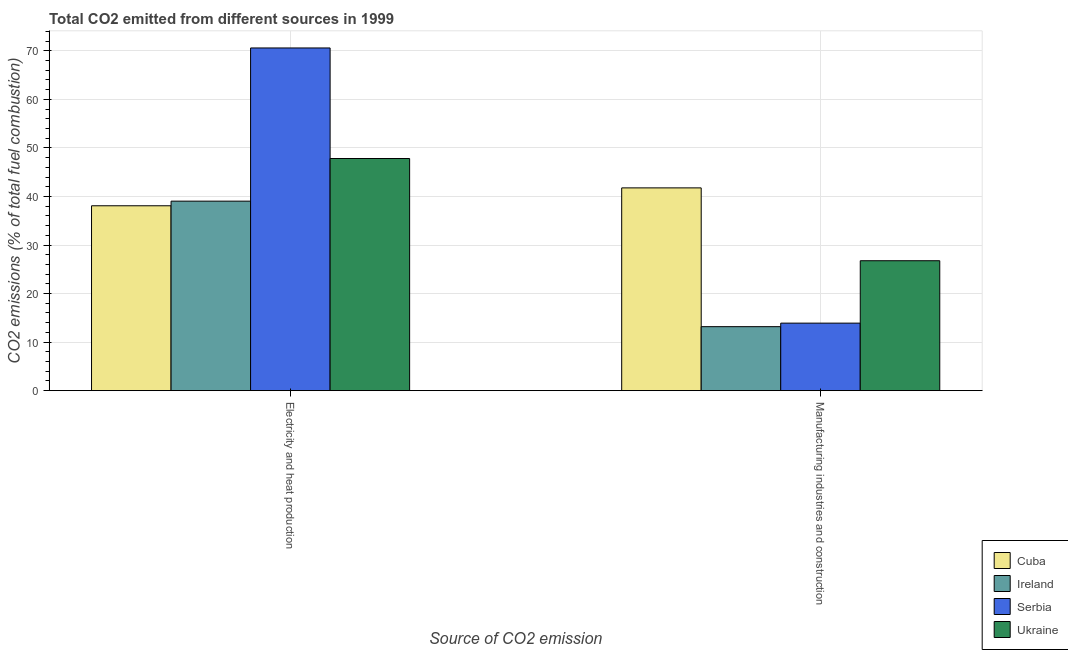How many groups of bars are there?
Provide a succinct answer. 2. How many bars are there on the 2nd tick from the left?
Keep it short and to the point. 4. What is the label of the 2nd group of bars from the left?
Provide a succinct answer. Manufacturing industries and construction. What is the co2 emissions due to manufacturing industries in Ireland?
Give a very brief answer. 13.18. Across all countries, what is the maximum co2 emissions due to electricity and heat production?
Keep it short and to the point. 70.6. Across all countries, what is the minimum co2 emissions due to electricity and heat production?
Provide a succinct answer. 38.09. In which country was the co2 emissions due to electricity and heat production maximum?
Give a very brief answer. Serbia. In which country was the co2 emissions due to manufacturing industries minimum?
Keep it short and to the point. Ireland. What is the total co2 emissions due to manufacturing industries in the graph?
Provide a succinct answer. 95.62. What is the difference between the co2 emissions due to electricity and heat production in Ukraine and that in Ireland?
Keep it short and to the point. 8.79. What is the difference between the co2 emissions due to manufacturing industries in Ukraine and the co2 emissions due to electricity and heat production in Ireland?
Offer a terse response. -12.27. What is the average co2 emissions due to electricity and heat production per country?
Your answer should be compact. 48.89. What is the difference between the co2 emissions due to electricity and heat production and co2 emissions due to manufacturing industries in Serbia?
Your response must be concise. 56.69. In how many countries, is the co2 emissions due to electricity and heat production greater than 6 %?
Offer a terse response. 4. What is the ratio of the co2 emissions due to manufacturing industries in Cuba to that in Serbia?
Offer a terse response. 3. Is the co2 emissions due to manufacturing industries in Ukraine less than that in Ireland?
Give a very brief answer. No. In how many countries, is the co2 emissions due to manufacturing industries greater than the average co2 emissions due to manufacturing industries taken over all countries?
Provide a succinct answer. 2. What does the 1st bar from the left in Manufacturing industries and construction represents?
Your response must be concise. Cuba. What does the 1st bar from the right in Electricity and heat production represents?
Provide a short and direct response. Ukraine. How many bars are there?
Keep it short and to the point. 8. Are all the bars in the graph horizontal?
Your answer should be compact. No. Does the graph contain any zero values?
Your answer should be compact. No. Where does the legend appear in the graph?
Make the answer very short. Bottom right. How many legend labels are there?
Your response must be concise. 4. How are the legend labels stacked?
Offer a very short reply. Vertical. What is the title of the graph?
Ensure brevity in your answer.  Total CO2 emitted from different sources in 1999. Does "Cambodia" appear as one of the legend labels in the graph?
Provide a succinct answer. No. What is the label or title of the X-axis?
Give a very brief answer. Source of CO2 emission. What is the label or title of the Y-axis?
Your answer should be very brief. CO2 emissions (% of total fuel combustion). What is the CO2 emissions (% of total fuel combustion) of Cuba in Electricity and heat production?
Offer a very short reply. 38.09. What is the CO2 emissions (% of total fuel combustion) in Ireland in Electricity and heat production?
Your answer should be compact. 39.04. What is the CO2 emissions (% of total fuel combustion) of Serbia in Electricity and heat production?
Your response must be concise. 70.6. What is the CO2 emissions (% of total fuel combustion) of Ukraine in Electricity and heat production?
Offer a very short reply. 47.82. What is the CO2 emissions (% of total fuel combustion) of Cuba in Manufacturing industries and construction?
Ensure brevity in your answer.  41.77. What is the CO2 emissions (% of total fuel combustion) of Ireland in Manufacturing industries and construction?
Offer a very short reply. 13.18. What is the CO2 emissions (% of total fuel combustion) of Serbia in Manufacturing industries and construction?
Provide a short and direct response. 13.91. What is the CO2 emissions (% of total fuel combustion) of Ukraine in Manufacturing industries and construction?
Provide a short and direct response. 26.76. Across all Source of CO2 emission, what is the maximum CO2 emissions (% of total fuel combustion) in Cuba?
Keep it short and to the point. 41.77. Across all Source of CO2 emission, what is the maximum CO2 emissions (% of total fuel combustion) of Ireland?
Your answer should be compact. 39.04. Across all Source of CO2 emission, what is the maximum CO2 emissions (% of total fuel combustion) in Serbia?
Give a very brief answer. 70.6. Across all Source of CO2 emission, what is the maximum CO2 emissions (% of total fuel combustion) in Ukraine?
Make the answer very short. 47.82. Across all Source of CO2 emission, what is the minimum CO2 emissions (% of total fuel combustion) in Cuba?
Your response must be concise. 38.09. Across all Source of CO2 emission, what is the minimum CO2 emissions (% of total fuel combustion) of Ireland?
Provide a succinct answer. 13.18. Across all Source of CO2 emission, what is the minimum CO2 emissions (% of total fuel combustion) in Serbia?
Offer a terse response. 13.91. Across all Source of CO2 emission, what is the minimum CO2 emissions (% of total fuel combustion) in Ukraine?
Offer a terse response. 26.76. What is the total CO2 emissions (% of total fuel combustion) of Cuba in the graph?
Keep it short and to the point. 79.86. What is the total CO2 emissions (% of total fuel combustion) in Ireland in the graph?
Provide a succinct answer. 52.22. What is the total CO2 emissions (% of total fuel combustion) in Serbia in the graph?
Offer a terse response. 84.5. What is the total CO2 emissions (% of total fuel combustion) of Ukraine in the graph?
Keep it short and to the point. 74.59. What is the difference between the CO2 emissions (% of total fuel combustion) in Cuba in Electricity and heat production and that in Manufacturing industries and construction?
Your answer should be compact. -3.69. What is the difference between the CO2 emissions (% of total fuel combustion) in Ireland in Electricity and heat production and that in Manufacturing industries and construction?
Provide a short and direct response. 25.86. What is the difference between the CO2 emissions (% of total fuel combustion) of Serbia in Electricity and heat production and that in Manufacturing industries and construction?
Ensure brevity in your answer.  56.69. What is the difference between the CO2 emissions (% of total fuel combustion) in Ukraine in Electricity and heat production and that in Manufacturing industries and construction?
Keep it short and to the point. 21.06. What is the difference between the CO2 emissions (% of total fuel combustion) in Cuba in Electricity and heat production and the CO2 emissions (% of total fuel combustion) in Ireland in Manufacturing industries and construction?
Provide a succinct answer. 24.91. What is the difference between the CO2 emissions (% of total fuel combustion) in Cuba in Electricity and heat production and the CO2 emissions (% of total fuel combustion) in Serbia in Manufacturing industries and construction?
Give a very brief answer. 24.18. What is the difference between the CO2 emissions (% of total fuel combustion) of Cuba in Electricity and heat production and the CO2 emissions (% of total fuel combustion) of Ukraine in Manufacturing industries and construction?
Your answer should be compact. 11.32. What is the difference between the CO2 emissions (% of total fuel combustion) of Ireland in Electricity and heat production and the CO2 emissions (% of total fuel combustion) of Serbia in Manufacturing industries and construction?
Provide a short and direct response. 25.13. What is the difference between the CO2 emissions (% of total fuel combustion) of Ireland in Electricity and heat production and the CO2 emissions (% of total fuel combustion) of Ukraine in Manufacturing industries and construction?
Your answer should be very brief. 12.27. What is the difference between the CO2 emissions (% of total fuel combustion) in Serbia in Electricity and heat production and the CO2 emissions (% of total fuel combustion) in Ukraine in Manufacturing industries and construction?
Your answer should be very brief. 43.83. What is the average CO2 emissions (% of total fuel combustion) in Cuba per Source of CO2 emission?
Keep it short and to the point. 39.93. What is the average CO2 emissions (% of total fuel combustion) of Ireland per Source of CO2 emission?
Your answer should be very brief. 26.11. What is the average CO2 emissions (% of total fuel combustion) in Serbia per Source of CO2 emission?
Give a very brief answer. 42.25. What is the average CO2 emissions (% of total fuel combustion) in Ukraine per Source of CO2 emission?
Your answer should be very brief. 37.29. What is the difference between the CO2 emissions (% of total fuel combustion) in Cuba and CO2 emissions (% of total fuel combustion) in Ireland in Electricity and heat production?
Your answer should be very brief. -0.95. What is the difference between the CO2 emissions (% of total fuel combustion) in Cuba and CO2 emissions (% of total fuel combustion) in Serbia in Electricity and heat production?
Keep it short and to the point. -32.51. What is the difference between the CO2 emissions (% of total fuel combustion) in Cuba and CO2 emissions (% of total fuel combustion) in Ukraine in Electricity and heat production?
Your answer should be very brief. -9.74. What is the difference between the CO2 emissions (% of total fuel combustion) in Ireland and CO2 emissions (% of total fuel combustion) in Serbia in Electricity and heat production?
Offer a terse response. -31.56. What is the difference between the CO2 emissions (% of total fuel combustion) in Ireland and CO2 emissions (% of total fuel combustion) in Ukraine in Electricity and heat production?
Provide a short and direct response. -8.79. What is the difference between the CO2 emissions (% of total fuel combustion) in Serbia and CO2 emissions (% of total fuel combustion) in Ukraine in Electricity and heat production?
Offer a very short reply. 22.77. What is the difference between the CO2 emissions (% of total fuel combustion) in Cuba and CO2 emissions (% of total fuel combustion) in Ireland in Manufacturing industries and construction?
Offer a very short reply. 28.59. What is the difference between the CO2 emissions (% of total fuel combustion) of Cuba and CO2 emissions (% of total fuel combustion) of Serbia in Manufacturing industries and construction?
Offer a very short reply. 27.86. What is the difference between the CO2 emissions (% of total fuel combustion) of Cuba and CO2 emissions (% of total fuel combustion) of Ukraine in Manufacturing industries and construction?
Provide a short and direct response. 15.01. What is the difference between the CO2 emissions (% of total fuel combustion) in Ireland and CO2 emissions (% of total fuel combustion) in Serbia in Manufacturing industries and construction?
Your response must be concise. -0.73. What is the difference between the CO2 emissions (% of total fuel combustion) in Ireland and CO2 emissions (% of total fuel combustion) in Ukraine in Manufacturing industries and construction?
Provide a short and direct response. -13.58. What is the difference between the CO2 emissions (% of total fuel combustion) of Serbia and CO2 emissions (% of total fuel combustion) of Ukraine in Manufacturing industries and construction?
Offer a very short reply. -12.86. What is the ratio of the CO2 emissions (% of total fuel combustion) in Cuba in Electricity and heat production to that in Manufacturing industries and construction?
Give a very brief answer. 0.91. What is the ratio of the CO2 emissions (% of total fuel combustion) of Ireland in Electricity and heat production to that in Manufacturing industries and construction?
Your response must be concise. 2.96. What is the ratio of the CO2 emissions (% of total fuel combustion) of Serbia in Electricity and heat production to that in Manufacturing industries and construction?
Provide a succinct answer. 5.08. What is the ratio of the CO2 emissions (% of total fuel combustion) of Ukraine in Electricity and heat production to that in Manufacturing industries and construction?
Make the answer very short. 1.79. What is the difference between the highest and the second highest CO2 emissions (% of total fuel combustion) of Cuba?
Your response must be concise. 3.69. What is the difference between the highest and the second highest CO2 emissions (% of total fuel combustion) in Ireland?
Your response must be concise. 25.86. What is the difference between the highest and the second highest CO2 emissions (% of total fuel combustion) in Serbia?
Your answer should be compact. 56.69. What is the difference between the highest and the second highest CO2 emissions (% of total fuel combustion) of Ukraine?
Make the answer very short. 21.06. What is the difference between the highest and the lowest CO2 emissions (% of total fuel combustion) in Cuba?
Your response must be concise. 3.69. What is the difference between the highest and the lowest CO2 emissions (% of total fuel combustion) in Ireland?
Provide a short and direct response. 25.86. What is the difference between the highest and the lowest CO2 emissions (% of total fuel combustion) in Serbia?
Keep it short and to the point. 56.69. What is the difference between the highest and the lowest CO2 emissions (% of total fuel combustion) in Ukraine?
Provide a short and direct response. 21.06. 